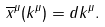Convert formula to latex. <formula><loc_0><loc_0><loc_500><loc_500>\overline { x } ^ { \mu } ( k ^ { \mu } ) = d k ^ { \mu } .</formula> 